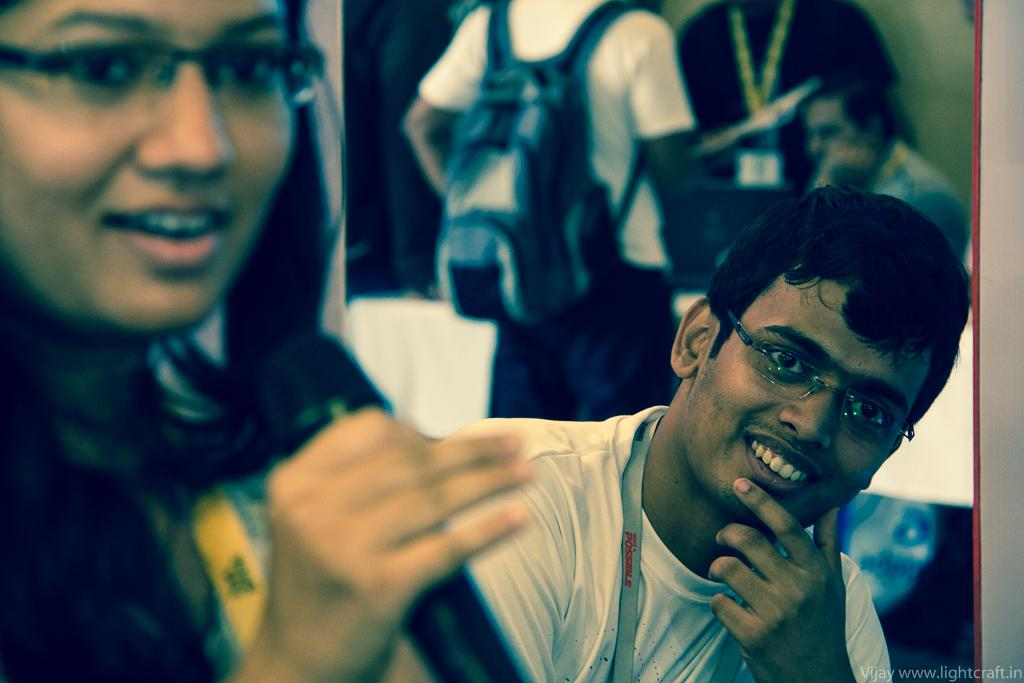How many people are in the image? There are persons in the image. Can you describe the backpack in the image? One person is wearing a backpack. How many persons are in the front of the image? There are two persons in the front. What is the gender of the person on the left side of the image? There is a woman on the left side of the image. What is the gender of the person on the right side of the image? There is a man on the right side of the image. What emotion is the cow displaying in the image? There is no cow present in the image, so it is not possible to determine the emotion it might be displaying. 